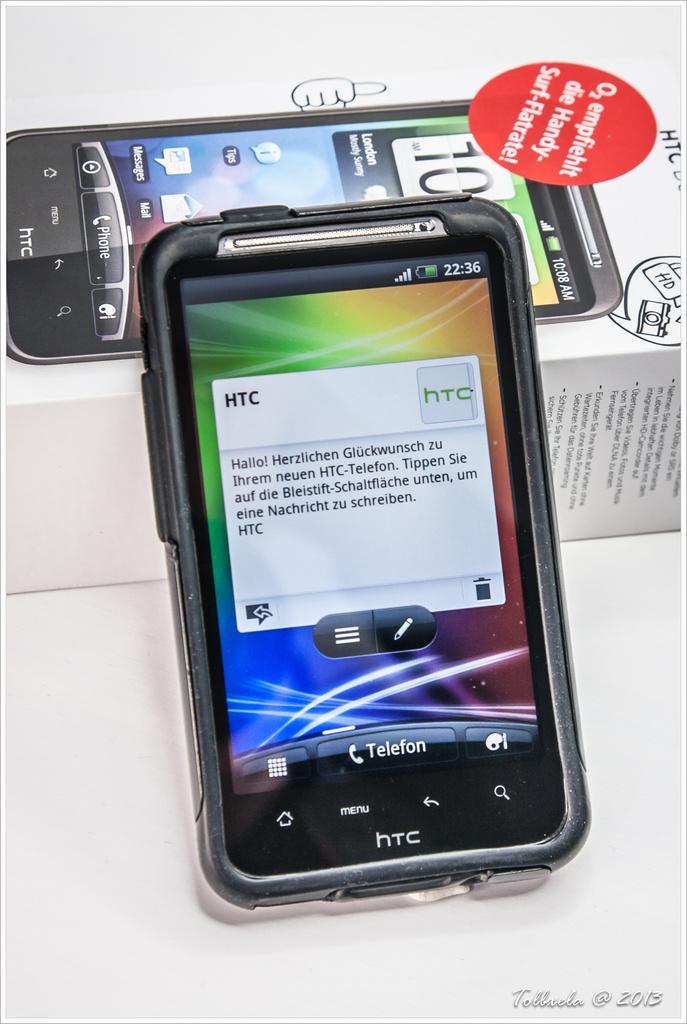Could you give a brief overview of what you see in this image? In this picture, we can see mobile phone and a box with some text and some images on it, we can see the white background, some text in the bottom right side of the picture. 